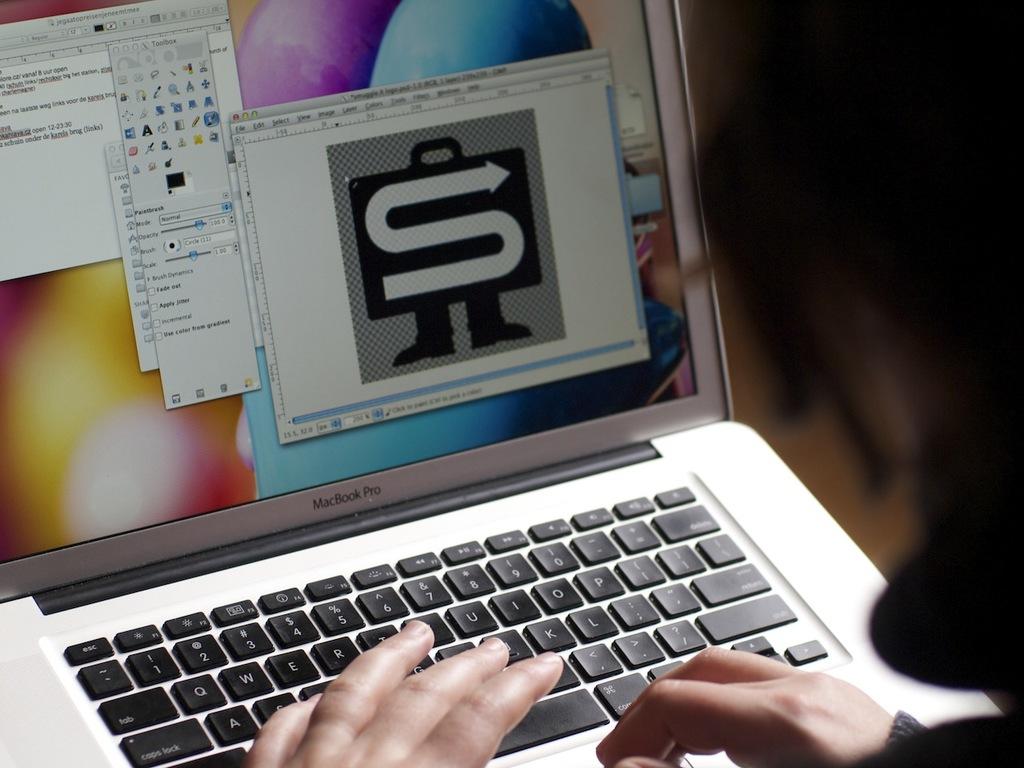What letter does the picture on the computer screen resemble?
Offer a terse response. S. 